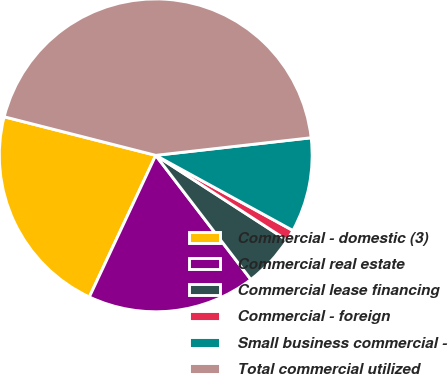Convert chart to OTSL. <chart><loc_0><loc_0><loc_500><loc_500><pie_chart><fcel>Commercial - domestic (3)<fcel>Commercial real estate<fcel>Commercial lease financing<fcel>Commercial - foreign<fcel>Small business commercial -<fcel>Total commercial utilized<nl><fcel>21.99%<fcel>17.38%<fcel>5.46%<fcel>1.16%<fcel>9.77%<fcel>44.24%<nl></chart> 